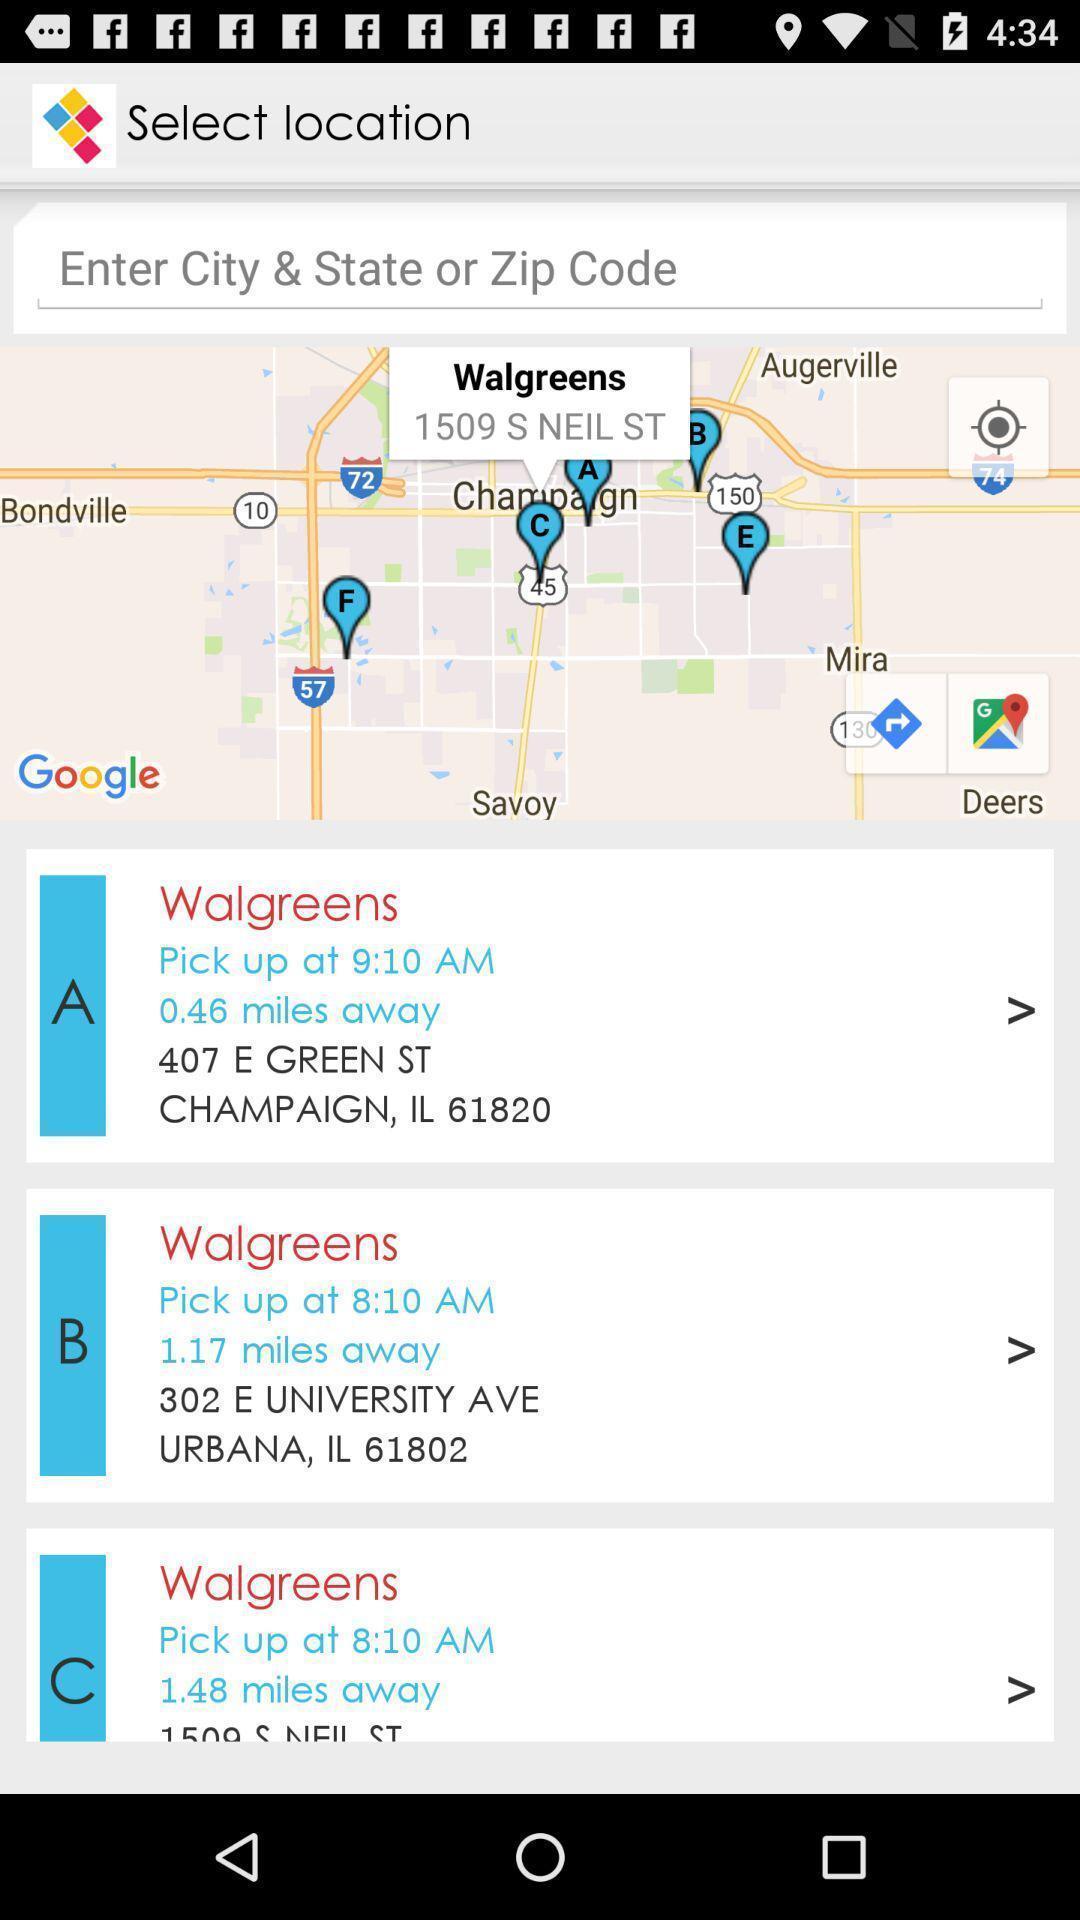Provide a textual representation of this image. Screen showing various photo design locations. 